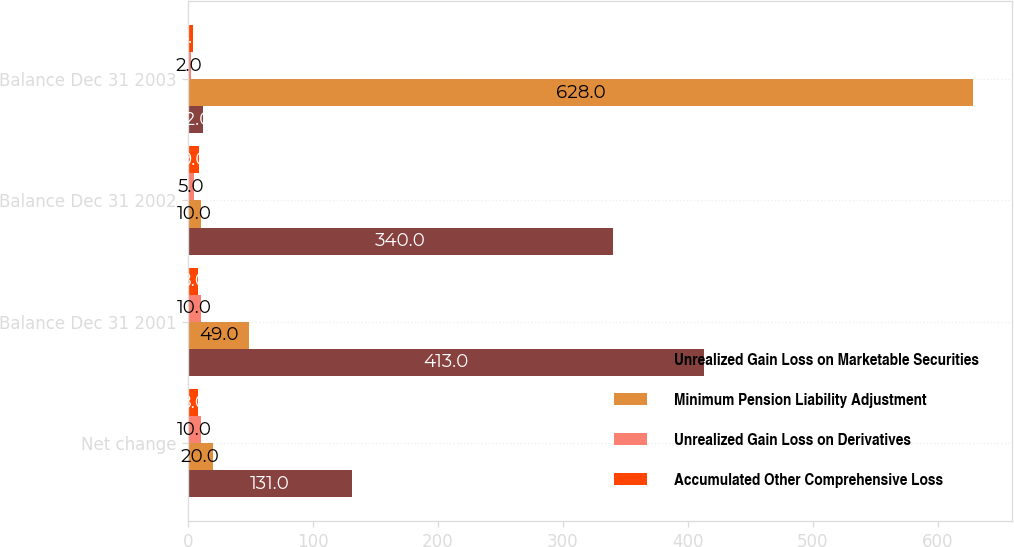<chart> <loc_0><loc_0><loc_500><loc_500><stacked_bar_chart><ecel><fcel>Net change<fcel>Balance Dec 31 2001<fcel>Balance Dec 31 2002<fcel>Balance Dec 31 2003<nl><fcel>Unrealized Gain Loss on Marketable Securities<fcel>131<fcel>413<fcel>340<fcel>12<nl><fcel>Minimum Pension Liability Adjustment<fcel>20<fcel>49<fcel>10<fcel>628<nl><fcel>Unrealized Gain Loss on Derivatives<fcel>10<fcel>10<fcel>5<fcel>2<nl><fcel>Accumulated Other Comprehensive Loss<fcel>8<fcel>8<fcel>9<fcel>4<nl></chart> 